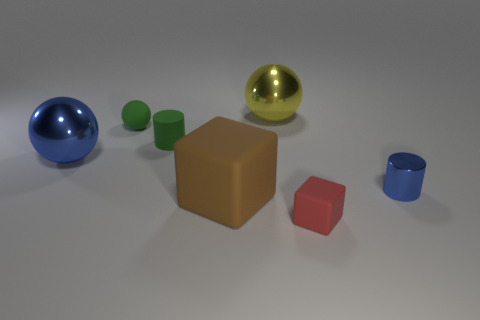What is the color of the small ball?
Your answer should be very brief. Green. There is a cylinder left of the small red rubber cube; does it have the same size as the metal thing on the left side of the large brown thing?
Offer a very short reply. No. Is the number of big blue things less than the number of big gray spheres?
Provide a short and direct response. No. How many big shiny balls are to the right of the green rubber sphere?
Your answer should be compact. 1. What material is the yellow thing?
Provide a succinct answer. Metal. Is the matte sphere the same color as the small matte cylinder?
Your answer should be compact. Yes. Are there fewer red rubber blocks that are to the left of the large blue ball than tiny green rubber cylinders?
Give a very brief answer. Yes. What color is the tiny cylinder to the right of the tiny rubber cylinder?
Keep it short and to the point. Blue. What is the shape of the big blue object?
Provide a short and direct response. Sphere. Are there any small matte objects that are behind the blue metal thing on the left side of the cylinder right of the large brown thing?
Provide a short and direct response. Yes. 